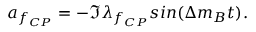<formula> <loc_0><loc_0><loc_500><loc_500>a _ { f _ { C P } } = - \Im \lambda _ { f _ { C P } } \sin ( \Delta m _ { B } t ) .</formula> 